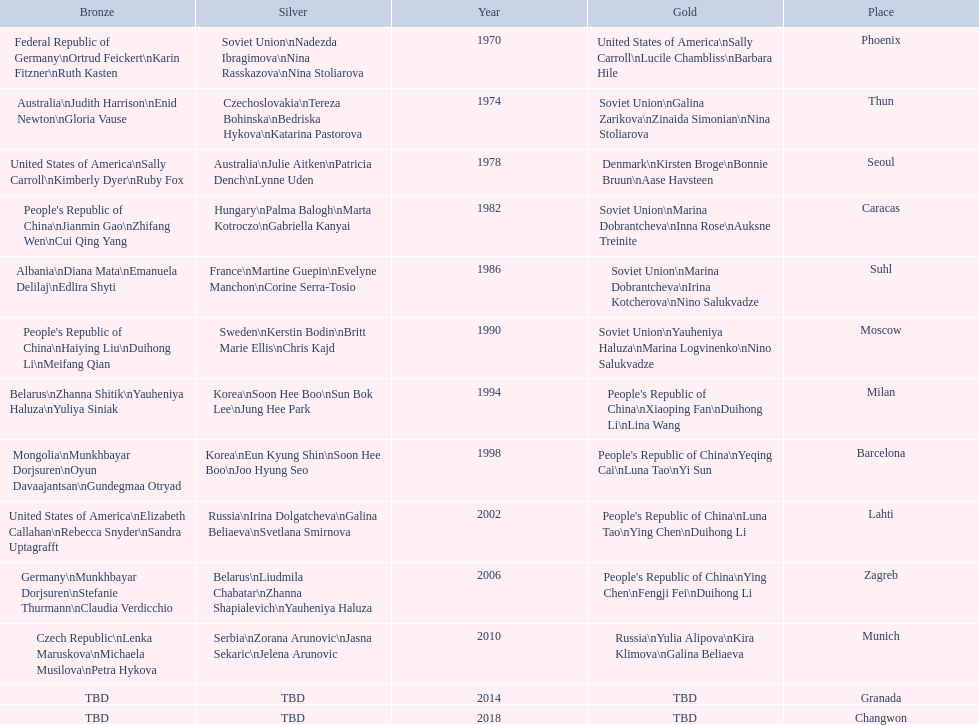What is the first place listed in this chart? Phoenix. 